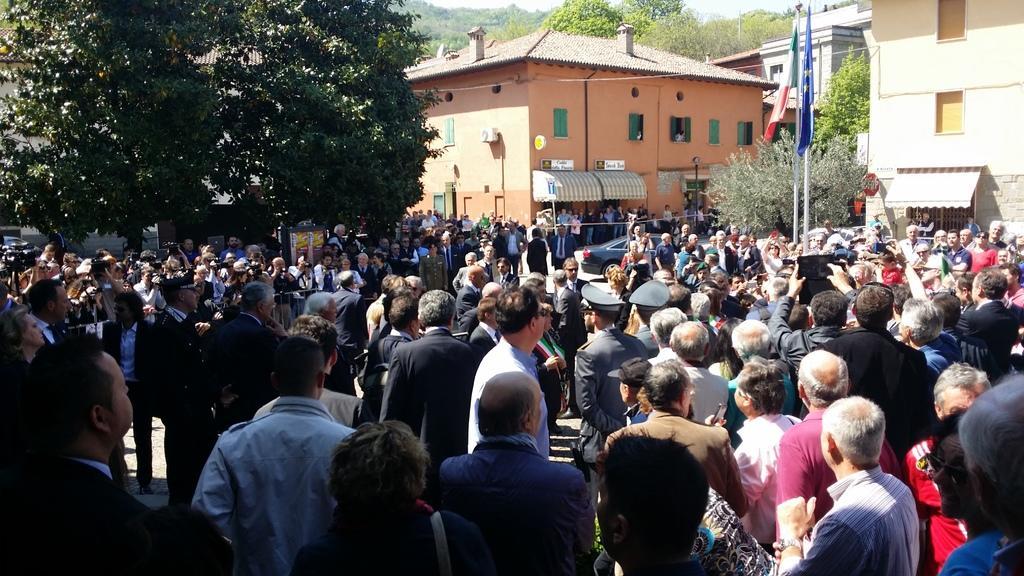Describe this image in one or two sentences. In the image there are many people standing on the land with buildings in the background and trees all over the place, there are flags on the right side. 